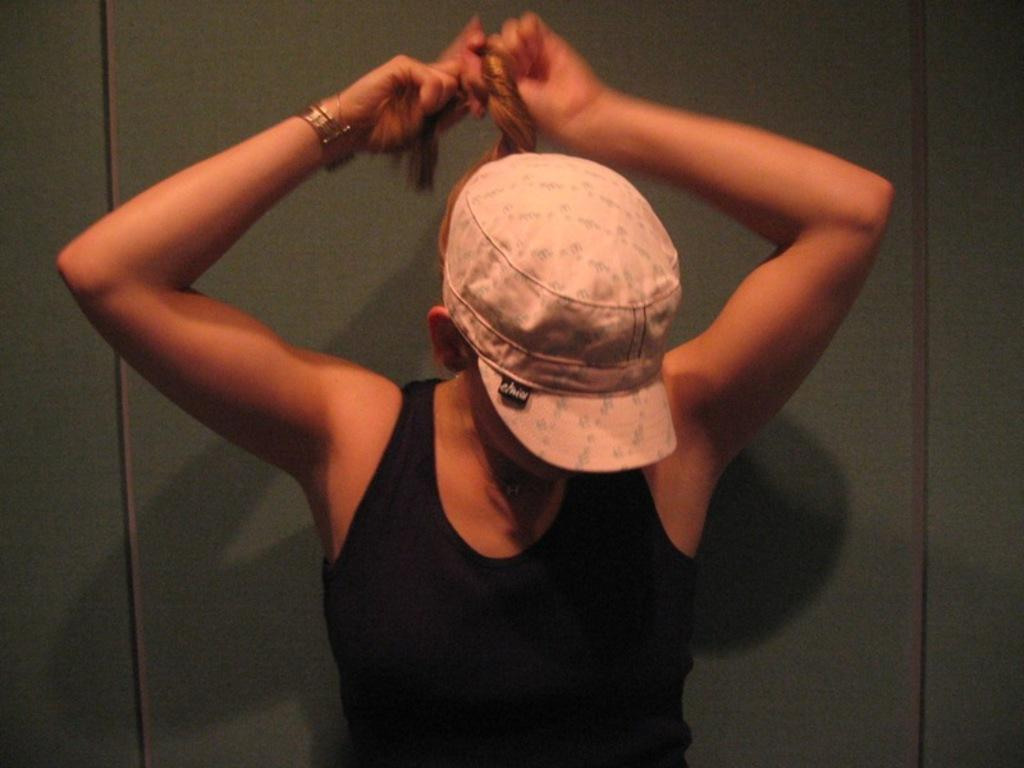Who is the main subject in the image? There is a woman in the image. What color is the background of the image? The background of the image is green. What is the range of the clock in the image? There is no clock present in the image, so there is no range to discuss. 